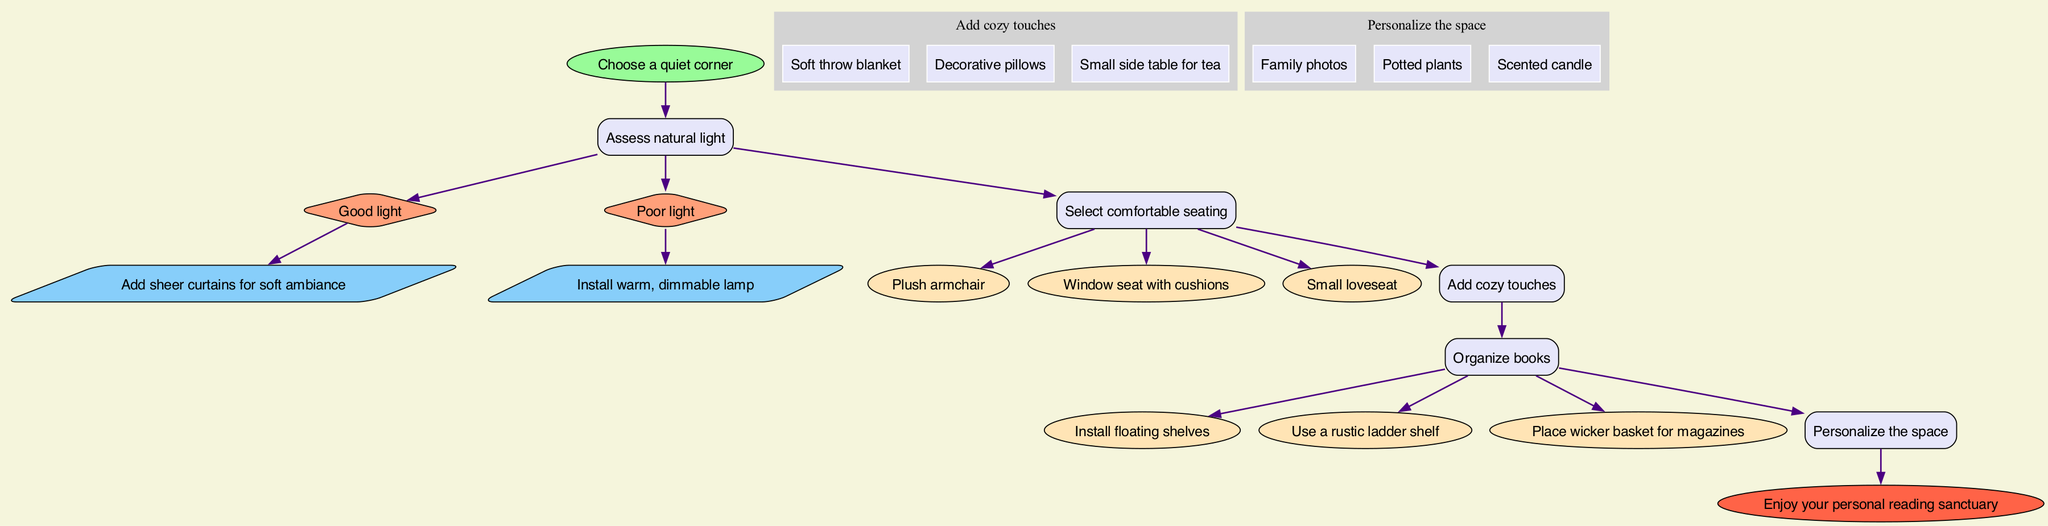What is the first step in creating a cozy reading nook? The diagram begins with the node that states "Choose a quiet corner," indicating that this is the initial action to take in the process.
Answer: Choose a quiet corner How many types of lighting options are suggested for natural light assessment? There are two options presented in the diagram for evaluating natural light: "Good light" and "Poor light." This indicates that there are two distinct lighting assessments to consider.
Answer: 2 What type of seating options are recommended? The steps include three options for seating: "Plush armchair," "Window seat with cushions," and "Small loveseat." These describe the seating choices one can consider for the reading nook.
Answer: Plush armchair, Window seat with cushions, Small loveseat What cozy touches can be added to the nook? The diagram lists three items under cozy touches, which are "Soft throw blanket," "Decorative pillows," and "Small side table for tea." These items aim to enhance comfort in the space.
Answer: Soft throw blanket, Decorative pillows, Small side table for tea Which step comes after selecting comfortable seating? The flow continues from "Select comfortable seating" to "Add cozy touches." This indicates that adding cozy elements is the subsequent action after seating selection.
Answer: Add cozy touches What is the last action to complete in the process? The end node of the diagram specifies "Enjoy your personal reading sanctuary," which indicates that this is the final action to take once all previous steps are completed.
Answer: Enjoy your personal reading sanctuary What decorative personalization items are suggested? The diagram enumerates three items for personalizing the nook: "Family photos," "Potted plants," and "Scented candle," highlighting ways to enhance the personal aspect of the space.
Answer: Family photos, Potted plants, Scented candle What type of shelves can be used for organizing books? The options include "Install floating shelves," "Use a rustic ladder shelf," and "Place wicker basket for magazines." These alternatives provide different organizational strategies for the books.
Answer: Install floating shelves, Use a rustic ladder shelf, Place wicker basket for magazines What color is the start node? The start node is filled with a light green color, indicated in the diagram where it says it has a fill color of "#98FB98." This coloration denotes the initial action visually.
Answer: Light green 